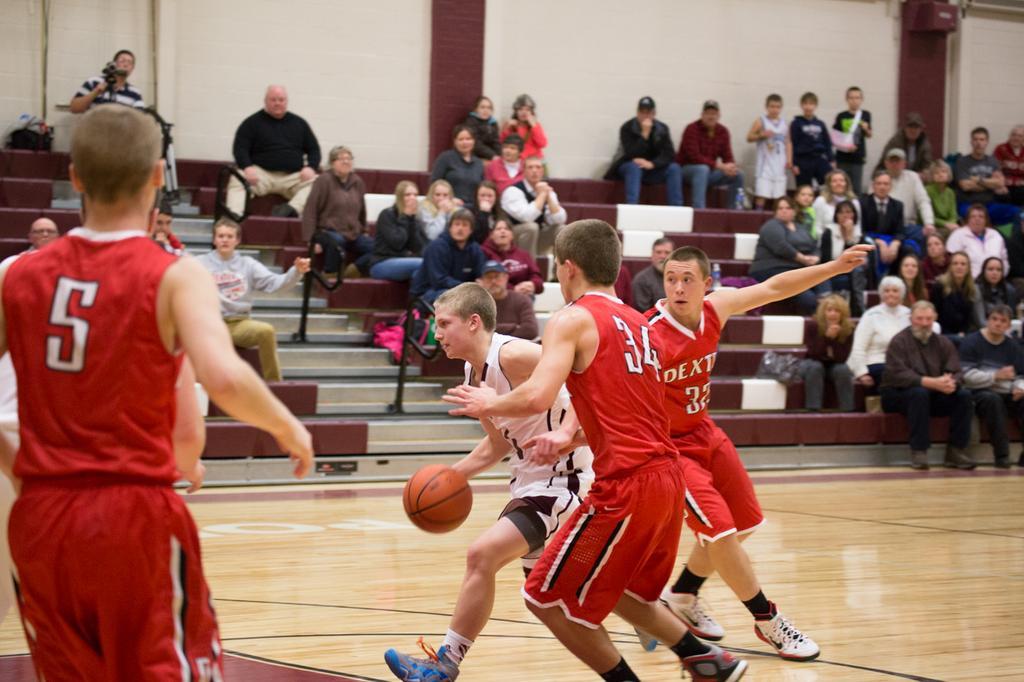Can you describe this image briefly? In this image in the foreground there are a group of people who are wearing jersey, and they are playing basketball. And in the background there are some people standing, and some of them are sitting and one person is holding a camera and there are rods and stairs. At the top of the image there is wall and pillars, and at the bottom there is floor. 